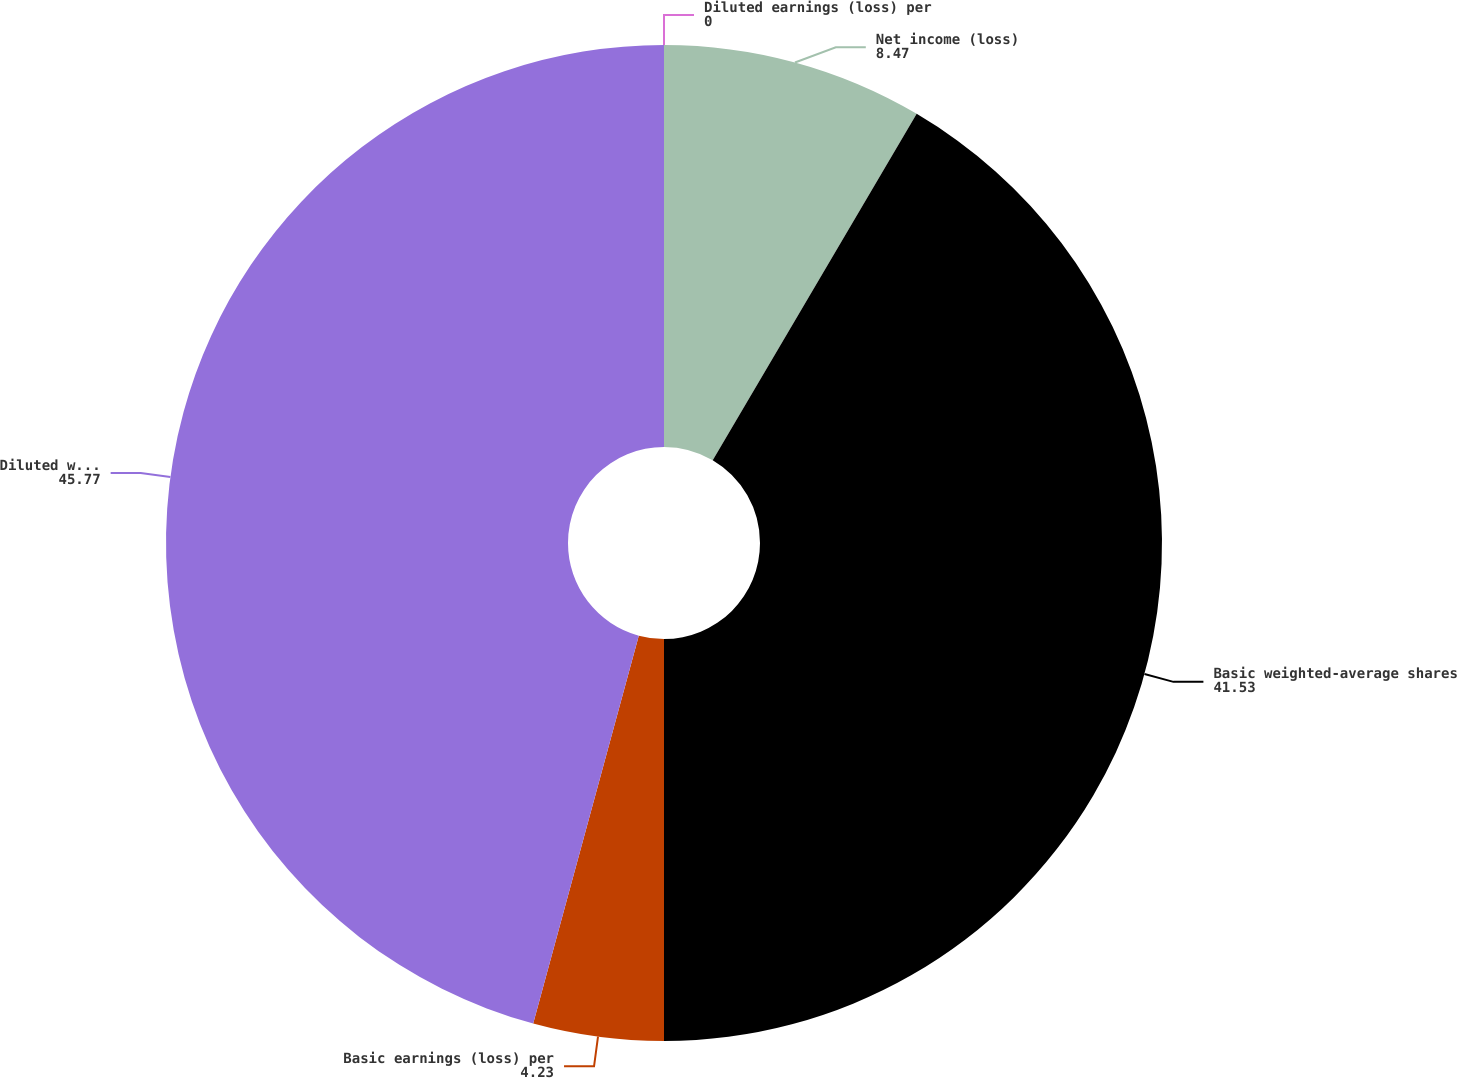<chart> <loc_0><loc_0><loc_500><loc_500><pie_chart><fcel>Net income (loss)<fcel>Basic weighted-average shares<fcel>Basic earnings (loss) per<fcel>Diluted weighted-average<fcel>Diluted earnings (loss) per<nl><fcel>8.47%<fcel>41.53%<fcel>4.23%<fcel>45.77%<fcel>0.0%<nl></chart> 